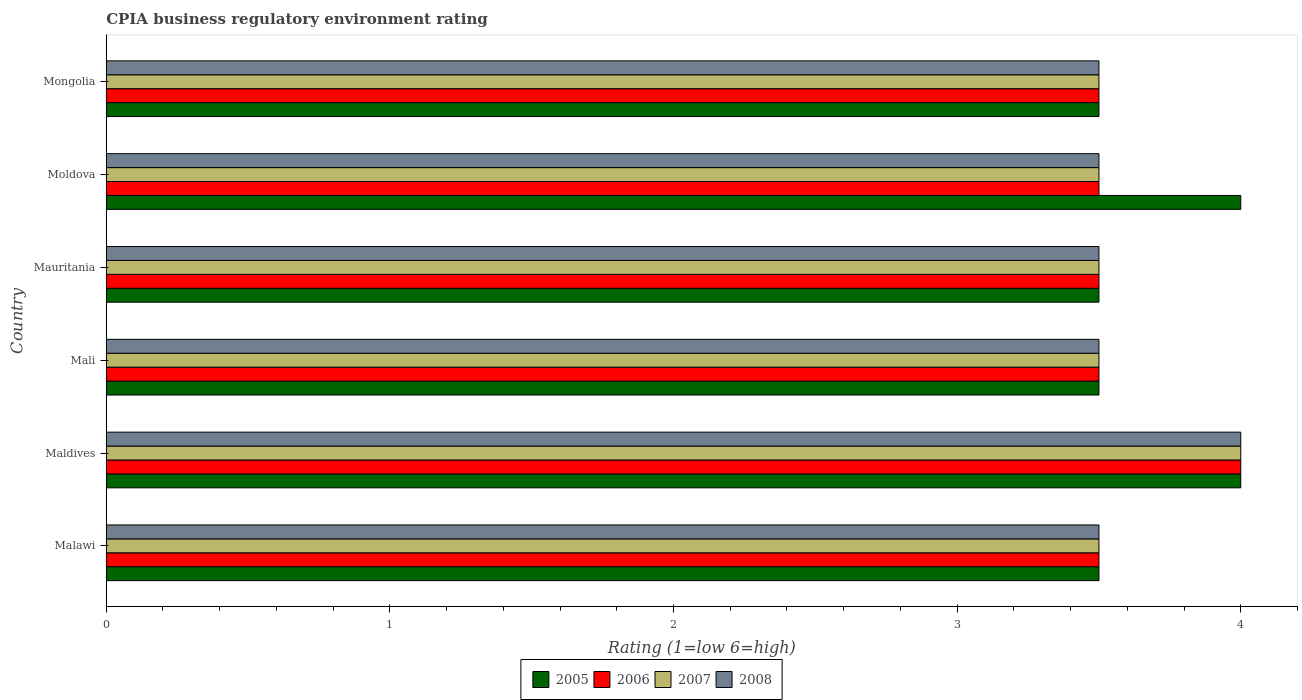Are the number of bars on each tick of the Y-axis equal?
Provide a succinct answer. Yes. How many bars are there on the 1st tick from the bottom?
Your answer should be very brief. 4. What is the label of the 3rd group of bars from the top?
Your answer should be compact. Mauritania. In how many cases, is the number of bars for a given country not equal to the number of legend labels?
Your response must be concise. 0. What is the CPIA rating in 2005 in Mali?
Your answer should be very brief. 3.5. Across all countries, what is the maximum CPIA rating in 2005?
Keep it short and to the point. 4. Across all countries, what is the minimum CPIA rating in 2005?
Provide a short and direct response. 3.5. In which country was the CPIA rating in 2007 maximum?
Your answer should be compact. Maldives. In which country was the CPIA rating in 2008 minimum?
Offer a very short reply. Malawi. What is the total CPIA rating in 2007 in the graph?
Your answer should be very brief. 21.5. What is the difference between the CPIA rating in 2005 in Mali and that in Mongolia?
Ensure brevity in your answer.  0. What is the average CPIA rating in 2008 per country?
Give a very brief answer. 3.58. In how many countries, is the CPIA rating in 2006 greater than 2.6 ?
Give a very brief answer. 6. What is the ratio of the CPIA rating in 2006 in Maldives to that in Moldova?
Provide a succinct answer. 1.14. What is the difference between the highest and the lowest CPIA rating in 2006?
Offer a terse response. 0.5. In how many countries, is the CPIA rating in 2008 greater than the average CPIA rating in 2008 taken over all countries?
Ensure brevity in your answer.  1. Is it the case that in every country, the sum of the CPIA rating in 2007 and CPIA rating in 2008 is greater than the sum of CPIA rating in 2006 and CPIA rating in 2005?
Your answer should be very brief. No. What does the 4th bar from the bottom in Mauritania represents?
Give a very brief answer. 2008. How many bars are there?
Your answer should be very brief. 24. Are all the bars in the graph horizontal?
Offer a very short reply. Yes. What is the difference between two consecutive major ticks on the X-axis?
Offer a terse response. 1. Does the graph contain any zero values?
Keep it short and to the point. No. How are the legend labels stacked?
Provide a short and direct response. Horizontal. What is the title of the graph?
Provide a short and direct response. CPIA business regulatory environment rating. What is the Rating (1=low 6=high) of 2007 in Malawi?
Your answer should be compact. 3.5. What is the Rating (1=low 6=high) in 2008 in Malawi?
Ensure brevity in your answer.  3.5. What is the Rating (1=low 6=high) in 2005 in Maldives?
Make the answer very short. 4. What is the Rating (1=low 6=high) in 2008 in Maldives?
Give a very brief answer. 4. What is the Rating (1=low 6=high) of 2007 in Mali?
Provide a succinct answer. 3.5. What is the Rating (1=low 6=high) of 2006 in Mauritania?
Make the answer very short. 3.5. What is the Rating (1=low 6=high) of 2007 in Mauritania?
Give a very brief answer. 3.5. What is the Rating (1=low 6=high) of 2006 in Moldova?
Keep it short and to the point. 3.5. What is the Rating (1=low 6=high) in 2007 in Moldova?
Give a very brief answer. 3.5. What is the Rating (1=low 6=high) of 2008 in Moldova?
Provide a short and direct response. 3.5. What is the Rating (1=low 6=high) in 2006 in Mongolia?
Your response must be concise. 3.5. What is the Rating (1=low 6=high) in 2008 in Mongolia?
Offer a terse response. 3.5. Across all countries, what is the maximum Rating (1=low 6=high) in 2005?
Ensure brevity in your answer.  4. Across all countries, what is the maximum Rating (1=low 6=high) in 2007?
Ensure brevity in your answer.  4. Across all countries, what is the minimum Rating (1=low 6=high) of 2005?
Your answer should be very brief. 3.5. Across all countries, what is the minimum Rating (1=low 6=high) in 2006?
Your answer should be very brief. 3.5. What is the total Rating (1=low 6=high) of 2006 in the graph?
Make the answer very short. 21.5. What is the total Rating (1=low 6=high) of 2007 in the graph?
Your answer should be very brief. 21.5. What is the total Rating (1=low 6=high) of 2008 in the graph?
Your answer should be very brief. 21.5. What is the difference between the Rating (1=low 6=high) of 2007 in Malawi and that in Maldives?
Your answer should be compact. -0.5. What is the difference between the Rating (1=low 6=high) in 2008 in Malawi and that in Maldives?
Provide a succinct answer. -0.5. What is the difference between the Rating (1=low 6=high) in 2005 in Malawi and that in Mali?
Your answer should be very brief. 0. What is the difference between the Rating (1=low 6=high) of 2006 in Malawi and that in Mauritania?
Offer a very short reply. 0. What is the difference between the Rating (1=low 6=high) in 2008 in Malawi and that in Mauritania?
Make the answer very short. 0. What is the difference between the Rating (1=low 6=high) in 2006 in Malawi and that in Moldova?
Provide a short and direct response. 0. What is the difference between the Rating (1=low 6=high) of 2005 in Malawi and that in Mongolia?
Offer a very short reply. 0. What is the difference between the Rating (1=low 6=high) in 2007 in Malawi and that in Mongolia?
Give a very brief answer. 0. What is the difference between the Rating (1=low 6=high) in 2008 in Malawi and that in Mongolia?
Provide a short and direct response. 0. What is the difference between the Rating (1=low 6=high) of 2005 in Maldives and that in Mali?
Offer a very short reply. 0.5. What is the difference between the Rating (1=low 6=high) of 2006 in Maldives and that in Mali?
Provide a short and direct response. 0.5. What is the difference between the Rating (1=low 6=high) of 2006 in Maldives and that in Mauritania?
Your answer should be compact. 0.5. What is the difference between the Rating (1=low 6=high) in 2005 in Maldives and that in Moldova?
Ensure brevity in your answer.  0. What is the difference between the Rating (1=low 6=high) of 2007 in Maldives and that in Moldova?
Provide a short and direct response. 0.5. What is the difference between the Rating (1=low 6=high) of 2008 in Maldives and that in Moldova?
Provide a short and direct response. 0.5. What is the difference between the Rating (1=low 6=high) in 2005 in Maldives and that in Mongolia?
Your answer should be compact. 0.5. What is the difference between the Rating (1=low 6=high) of 2006 in Maldives and that in Mongolia?
Keep it short and to the point. 0.5. What is the difference between the Rating (1=low 6=high) of 2005 in Mali and that in Mauritania?
Your answer should be very brief. 0. What is the difference between the Rating (1=low 6=high) in 2007 in Mali and that in Moldova?
Give a very brief answer. 0. What is the difference between the Rating (1=low 6=high) in 2005 in Mali and that in Mongolia?
Provide a short and direct response. 0. What is the difference between the Rating (1=low 6=high) in 2007 in Mali and that in Mongolia?
Your answer should be very brief. 0. What is the difference between the Rating (1=low 6=high) of 2008 in Mali and that in Mongolia?
Keep it short and to the point. 0. What is the difference between the Rating (1=low 6=high) of 2005 in Mauritania and that in Moldova?
Your answer should be very brief. -0.5. What is the difference between the Rating (1=low 6=high) of 2006 in Mauritania and that in Moldova?
Offer a terse response. 0. What is the difference between the Rating (1=low 6=high) of 2007 in Mauritania and that in Moldova?
Give a very brief answer. 0. What is the difference between the Rating (1=low 6=high) in 2007 in Mauritania and that in Mongolia?
Make the answer very short. 0. What is the difference between the Rating (1=low 6=high) in 2008 in Mauritania and that in Mongolia?
Offer a very short reply. 0. What is the difference between the Rating (1=low 6=high) of 2007 in Moldova and that in Mongolia?
Provide a succinct answer. 0. What is the difference between the Rating (1=low 6=high) of 2008 in Moldova and that in Mongolia?
Offer a very short reply. 0. What is the difference between the Rating (1=low 6=high) of 2007 in Malawi and the Rating (1=low 6=high) of 2008 in Maldives?
Make the answer very short. -0.5. What is the difference between the Rating (1=low 6=high) in 2005 in Malawi and the Rating (1=low 6=high) in 2006 in Mali?
Your answer should be very brief. 0. What is the difference between the Rating (1=low 6=high) of 2005 in Malawi and the Rating (1=low 6=high) of 2007 in Mali?
Keep it short and to the point. 0. What is the difference between the Rating (1=low 6=high) in 2005 in Malawi and the Rating (1=low 6=high) in 2008 in Mali?
Make the answer very short. 0. What is the difference between the Rating (1=low 6=high) in 2006 in Malawi and the Rating (1=low 6=high) in 2008 in Mali?
Ensure brevity in your answer.  0. What is the difference between the Rating (1=low 6=high) of 2007 in Malawi and the Rating (1=low 6=high) of 2008 in Mali?
Provide a short and direct response. 0. What is the difference between the Rating (1=low 6=high) in 2006 in Malawi and the Rating (1=low 6=high) in 2007 in Mauritania?
Make the answer very short. 0. What is the difference between the Rating (1=low 6=high) in 2006 in Malawi and the Rating (1=low 6=high) in 2008 in Mauritania?
Provide a short and direct response. 0. What is the difference between the Rating (1=low 6=high) in 2005 in Malawi and the Rating (1=low 6=high) in 2006 in Moldova?
Ensure brevity in your answer.  0. What is the difference between the Rating (1=low 6=high) of 2005 in Malawi and the Rating (1=low 6=high) of 2007 in Moldova?
Ensure brevity in your answer.  0. What is the difference between the Rating (1=low 6=high) in 2005 in Malawi and the Rating (1=low 6=high) in 2008 in Moldova?
Ensure brevity in your answer.  0. What is the difference between the Rating (1=low 6=high) of 2006 in Malawi and the Rating (1=low 6=high) of 2007 in Moldova?
Keep it short and to the point. 0. What is the difference between the Rating (1=low 6=high) of 2006 in Malawi and the Rating (1=low 6=high) of 2008 in Moldova?
Your answer should be very brief. 0. What is the difference between the Rating (1=low 6=high) in 2005 in Malawi and the Rating (1=low 6=high) in 2006 in Mongolia?
Your answer should be very brief. 0. What is the difference between the Rating (1=low 6=high) of 2005 in Malawi and the Rating (1=low 6=high) of 2008 in Mongolia?
Give a very brief answer. 0. What is the difference between the Rating (1=low 6=high) of 2006 in Malawi and the Rating (1=low 6=high) of 2008 in Mongolia?
Make the answer very short. 0. What is the difference between the Rating (1=low 6=high) in 2007 in Malawi and the Rating (1=low 6=high) in 2008 in Mongolia?
Your response must be concise. 0. What is the difference between the Rating (1=low 6=high) of 2005 in Maldives and the Rating (1=low 6=high) of 2006 in Mali?
Provide a succinct answer. 0.5. What is the difference between the Rating (1=low 6=high) in 2005 in Maldives and the Rating (1=low 6=high) in 2007 in Mali?
Provide a short and direct response. 0.5. What is the difference between the Rating (1=low 6=high) in 2005 in Maldives and the Rating (1=low 6=high) in 2008 in Mali?
Your answer should be compact. 0.5. What is the difference between the Rating (1=low 6=high) in 2006 in Maldives and the Rating (1=low 6=high) in 2008 in Mali?
Offer a terse response. 0.5. What is the difference between the Rating (1=low 6=high) of 2007 in Maldives and the Rating (1=low 6=high) of 2008 in Mali?
Ensure brevity in your answer.  0.5. What is the difference between the Rating (1=low 6=high) in 2005 in Maldives and the Rating (1=low 6=high) in 2007 in Mauritania?
Offer a very short reply. 0.5. What is the difference between the Rating (1=low 6=high) of 2005 in Maldives and the Rating (1=low 6=high) of 2008 in Mauritania?
Offer a very short reply. 0.5. What is the difference between the Rating (1=low 6=high) in 2005 in Maldives and the Rating (1=low 6=high) in 2006 in Moldova?
Give a very brief answer. 0.5. What is the difference between the Rating (1=low 6=high) of 2005 in Maldives and the Rating (1=low 6=high) of 2007 in Moldova?
Provide a short and direct response. 0.5. What is the difference between the Rating (1=low 6=high) in 2006 in Maldives and the Rating (1=low 6=high) in 2007 in Moldova?
Provide a succinct answer. 0.5. What is the difference between the Rating (1=low 6=high) in 2006 in Maldives and the Rating (1=low 6=high) in 2008 in Moldova?
Make the answer very short. 0.5. What is the difference between the Rating (1=low 6=high) in 2007 in Maldives and the Rating (1=low 6=high) in 2008 in Moldova?
Give a very brief answer. 0.5. What is the difference between the Rating (1=low 6=high) of 2005 in Maldives and the Rating (1=low 6=high) of 2006 in Mongolia?
Keep it short and to the point. 0.5. What is the difference between the Rating (1=low 6=high) in 2005 in Maldives and the Rating (1=low 6=high) in 2007 in Mongolia?
Provide a succinct answer. 0.5. What is the difference between the Rating (1=low 6=high) of 2006 in Maldives and the Rating (1=low 6=high) of 2007 in Mongolia?
Keep it short and to the point. 0.5. What is the difference between the Rating (1=low 6=high) of 2007 in Maldives and the Rating (1=low 6=high) of 2008 in Mongolia?
Your response must be concise. 0.5. What is the difference between the Rating (1=low 6=high) of 2005 in Mali and the Rating (1=low 6=high) of 2006 in Mauritania?
Provide a short and direct response. 0. What is the difference between the Rating (1=low 6=high) in 2005 in Mali and the Rating (1=low 6=high) in 2007 in Mauritania?
Ensure brevity in your answer.  0. What is the difference between the Rating (1=low 6=high) of 2006 in Mali and the Rating (1=low 6=high) of 2007 in Mauritania?
Your answer should be compact. 0. What is the difference between the Rating (1=low 6=high) of 2006 in Mali and the Rating (1=low 6=high) of 2008 in Mauritania?
Ensure brevity in your answer.  0. What is the difference between the Rating (1=low 6=high) of 2007 in Mali and the Rating (1=low 6=high) of 2008 in Mauritania?
Your answer should be compact. 0. What is the difference between the Rating (1=low 6=high) of 2007 in Mali and the Rating (1=low 6=high) of 2008 in Moldova?
Your answer should be very brief. 0. What is the difference between the Rating (1=low 6=high) of 2005 in Mali and the Rating (1=low 6=high) of 2007 in Mongolia?
Provide a short and direct response. 0. What is the difference between the Rating (1=low 6=high) of 2005 in Mali and the Rating (1=low 6=high) of 2008 in Mongolia?
Keep it short and to the point. 0. What is the difference between the Rating (1=low 6=high) in 2006 in Mali and the Rating (1=low 6=high) in 2007 in Mongolia?
Your answer should be very brief. 0. What is the difference between the Rating (1=low 6=high) of 2006 in Mali and the Rating (1=low 6=high) of 2008 in Mongolia?
Provide a short and direct response. 0. What is the difference between the Rating (1=low 6=high) in 2005 in Mauritania and the Rating (1=low 6=high) in 2008 in Moldova?
Your answer should be very brief. 0. What is the difference between the Rating (1=low 6=high) of 2006 in Mauritania and the Rating (1=low 6=high) of 2007 in Moldova?
Give a very brief answer. 0. What is the difference between the Rating (1=low 6=high) of 2006 in Mauritania and the Rating (1=low 6=high) of 2008 in Moldova?
Provide a short and direct response. 0. What is the difference between the Rating (1=low 6=high) in 2007 in Mauritania and the Rating (1=low 6=high) in 2008 in Moldova?
Your response must be concise. 0. What is the difference between the Rating (1=low 6=high) in 2005 in Mauritania and the Rating (1=low 6=high) in 2006 in Mongolia?
Ensure brevity in your answer.  0. What is the difference between the Rating (1=low 6=high) in 2005 in Mauritania and the Rating (1=low 6=high) in 2007 in Mongolia?
Offer a terse response. 0. What is the difference between the Rating (1=low 6=high) of 2005 in Mauritania and the Rating (1=low 6=high) of 2008 in Mongolia?
Provide a short and direct response. 0. What is the difference between the Rating (1=low 6=high) in 2006 in Mauritania and the Rating (1=low 6=high) in 2008 in Mongolia?
Make the answer very short. 0. What is the average Rating (1=low 6=high) in 2005 per country?
Provide a short and direct response. 3.67. What is the average Rating (1=low 6=high) in 2006 per country?
Offer a terse response. 3.58. What is the average Rating (1=low 6=high) in 2007 per country?
Ensure brevity in your answer.  3.58. What is the average Rating (1=low 6=high) of 2008 per country?
Offer a very short reply. 3.58. What is the difference between the Rating (1=low 6=high) of 2005 and Rating (1=low 6=high) of 2007 in Malawi?
Your response must be concise. 0. What is the difference between the Rating (1=low 6=high) of 2006 and Rating (1=low 6=high) of 2007 in Malawi?
Keep it short and to the point. 0. What is the difference between the Rating (1=low 6=high) in 2006 and Rating (1=low 6=high) in 2008 in Malawi?
Give a very brief answer. 0. What is the difference between the Rating (1=low 6=high) in 2007 and Rating (1=low 6=high) in 2008 in Malawi?
Offer a terse response. 0. What is the difference between the Rating (1=low 6=high) of 2005 and Rating (1=low 6=high) of 2006 in Maldives?
Ensure brevity in your answer.  0. What is the difference between the Rating (1=low 6=high) of 2005 and Rating (1=low 6=high) of 2008 in Maldives?
Your response must be concise. 0. What is the difference between the Rating (1=low 6=high) in 2006 and Rating (1=low 6=high) in 2007 in Maldives?
Provide a succinct answer. 0. What is the difference between the Rating (1=low 6=high) of 2006 and Rating (1=low 6=high) of 2008 in Maldives?
Ensure brevity in your answer.  0. What is the difference between the Rating (1=low 6=high) in 2007 and Rating (1=low 6=high) in 2008 in Maldives?
Offer a very short reply. 0. What is the difference between the Rating (1=low 6=high) of 2005 and Rating (1=low 6=high) of 2008 in Mali?
Offer a terse response. 0. What is the difference between the Rating (1=low 6=high) of 2006 and Rating (1=low 6=high) of 2007 in Mali?
Make the answer very short. 0. What is the difference between the Rating (1=low 6=high) in 2007 and Rating (1=low 6=high) in 2008 in Mali?
Offer a terse response. 0. What is the difference between the Rating (1=low 6=high) in 2005 and Rating (1=low 6=high) in 2007 in Mauritania?
Offer a very short reply. 0. What is the difference between the Rating (1=low 6=high) in 2005 and Rating (1=low 6=high) in 2008 in Mauritania?
Provide a succinct answer. 0. What is the difference between the Rating (1=low 6=high) of 2006 and Rating (1=low 6=high) of 2008 in Mauritania?
Make the answer very short. 0. What is the difference between the Rating (1=low 6=high) of 2006 and Rating (1=low 6=high) of 2007 in Moldova?
Make the answer very short. 0. What is the difference between the Rating (1=low 6=high) of 2006 and Rating (1=low 6=high) of 2008 in Moldova?
Make the answer very short. 0. What is the difference between the Rating (1=low 6=high) of 2007 and Rating (1=low 6=high) of 2008 in Mongolia?
Give a very brief answer. 0. What is the ratio of the Rating (1=low 6=high) in 2005 in Malawi to that in Maldives?
Your answer should be very brief. 0.88. What is the ratio of the Rating (1=low 6=high) in 2006 in Malawi to that in Maldives?
Give a very brief answer. 0.88. What is the ratio of the Rating (1=low 6=high) in 2007 in Malawi to that in Maldives?
Offer a very short reply. 0.88. What is the ratio of the Rating (1=low 6=high) in 2008 in Malawi to that in Maldives?
Provide a short and direct response. 0.88. What is the ratio of the Rating (1=low 6=high) in 2006 in Malawi to that in Mali?
Provide a succinct answer. 1. What is the ratio of the Rating (1=low 6=high) of 2008 in Malawi to that in Mali?
Offer a terse response. 1. What is the ratio of the Rating (1=low 6=high) of 2005 in Malawi to that in Moldova?
Give a very brief answer. 0.88. What is the ratio of the Rating (1=low 6=high) in 2006 in Malawi to that in Moldova?
Give a very brief answer. 1. What is the ratio of the Rating (1=low 6=high) of 2005 in Malawi to that in Mongolia?
Give a very brief answer. 1. What is the ratio of the Rating (1=low 6=high) of 2008 in Malawi to that in Mongolia?
Give a very brief answer. 1. What is the ratio of the Rating (1=low 6=high) of 2005 in Maldives to that in Mauritania?
Offer a very short reply. 1.14. What is the ratio of the Rating (1=low 6=high) in 2006 in Maldives to that in Mauritania?
Keep it short and to the point. 1.14. What is the ratio of the Rating (1=low 6=high) in 2007 in Maldives to that in Moldova?
Offer a terse response. 1.14. What is the ratio of the Rating (1=low 6=high) of 2005 in Maldives to that in Mongolia?
Provide a succinct answer. 1.14. What is the ratio of the Rating (1=low 6=high) of 2006 in Maldives to that in Mongolia?
Make the answer very short. 1.14. What is the ratio of the Rating (1=low 6=high) in 2005 in Mali to that in Mauritania?
Offer a terse response. 1. What is the ratio of the Rating (1=low 6=high) in 2007 in Mali to that in Mauritania?
Give a very brief answer. 1. What is the ratio of the Rating (1=low 6=high) of 2008 in Mali to that in Mauritania?
Make the answer very short. 1. What is the ratio of the Rating (1=low 6=high) of 2006 in Mali to that in Moldova?
Keep it short and to the point. 1. What is the ratio of the Rating (1=low 6=high) of 2007 in Mali to that in Moldova?
Ensure brevity in your answer.  1. What is the ratio of the Rating (1=low 6=high) in 2008 in Mali to that in Moldova?
Give a very brief answer. 1. What is the ratio of the Rating (1=low 6=high) of 2006 in Mali to that in Mongolia?
Your answer should be very brief. 1. What is the ratio of the Rating (1=low 6=high) of 2007 in Mali to that in Mongolia?
Provide a succinct answer. 1. What is the ratio of the Rating (1=low 6=high) of 2006 in Mauritania to that in Moldova?
Your answer should be very brief. 1. What is the ratio of the Rating (1=low 6=high) of 2007 in Mauritania to that in Moldova?
Give a very brief answer. 1. What is the ratio of the Rating (1=low 6=high) in 2008 in Mauritania to that in Moldova?
Your answer should be compact. 1. What is the ratio of the Rating (1=low 6=high) in 2007 in Mauritania to that in Mongolia?
Make the answer very short. 1. What is the ratio of the Rating (1=low 6=high) in 2008 in Mauritania to that in Mongolia?
Offer a very short reply. 1. What is the ratio of the Rating (1=low 6=high) of 2007 in Moldova to that in Mongolia?
Your answer should be compact. 1. What is the ratio of the Rating (1=low 6=high) of 2008 in Moldova to that in Mongolia?
Your answer should be compact. 1. What is the difference between the highest and the second highest Rating (1=low 6=high) of 2007?
Keep it short and to the point. 0.5. What is the difference between the highest and the lowest Rating (1=low 6=high) of 2006?
Your answer should be compact. 0.5. What is the difference between the highest and the lowest Rating (1=low 6=high) in 2007?
Make the answer very short. 0.5. 